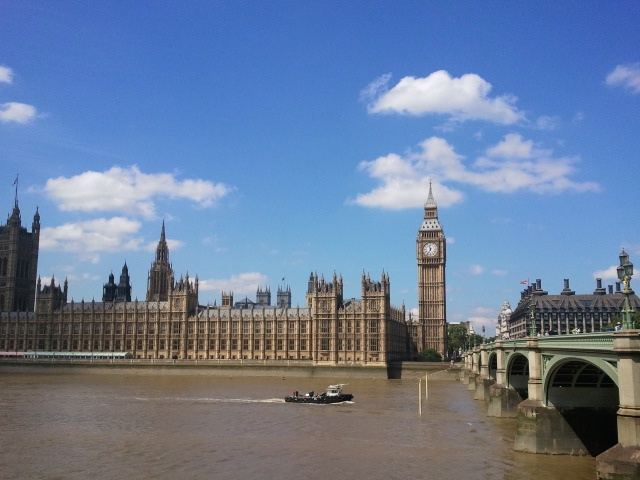Describe the objects in this image and their specific colors. I can see boat in blue, black, gray, and darkgray tones, clock in blue, darkgray, lightgray, and gray tones, people in blue, gray, black, darkgray, and teal tones, people in blue, black, gray, and maroon tones, and people in blue, maroon, brown, and black tones in this image. 